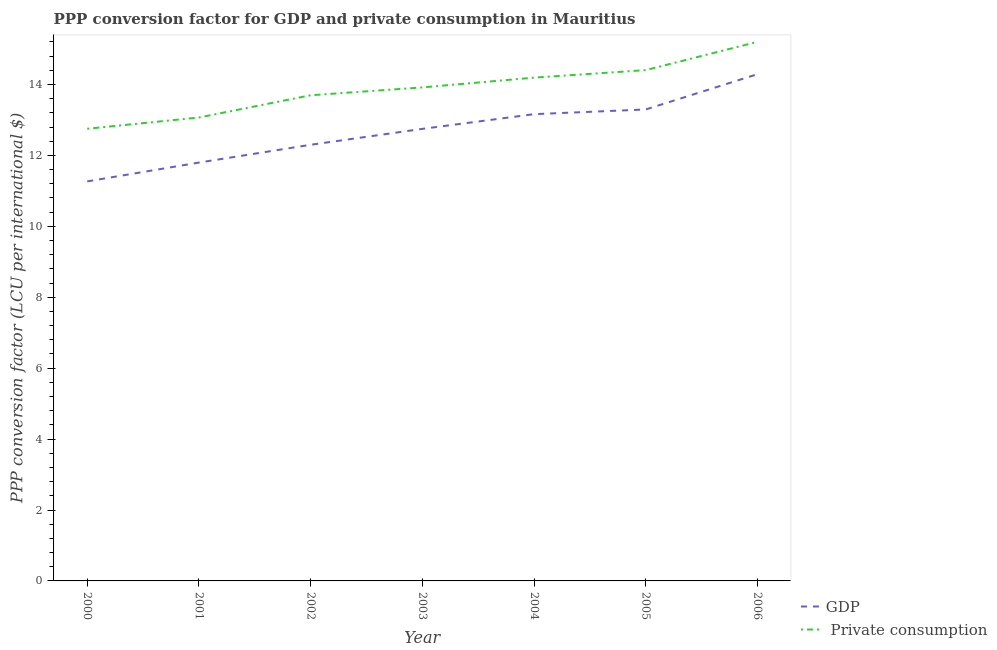How many different coloured lines are there?
Your response must be concise. 2. What is the ppp conversion factor for gdp in 2002?
Offer a very short reply. 12.3. Across all years, what is the maximum ppp conversion factor for private consumption?
Make the answer very short. 15.2. Across all years, what is the minimum ppp conversion factor for gdp?
Your response must be concise. 11.27. What is the total ppp conversion factor for private consumption in the graph?
Provide a short and direct response. 97.24. What is the difference between the ppp conversion factor for private consumption in 2001 and that in 2003?
Provide a short and direct response. -0.85. What is the difference between the ppp conversion factor for private consumption in 2003 and the ppp conversion factor for gdp in 2001?
Your answer should be compact. 2.12. What is the average ppp conversion factor for gdp per year?
Offer a terse response. 12.7. In the year 2003, what is the difference between the ppp conversion factor for gdp and ppp conversion factor for private consumption?
Provide a short and direct response. -1.17. In how many years, is the ppp conversion factor for private consumption greater than 11.2 LCU?
Your answer should be very brief. 7. What is the ratio of the ppp conversion factor for private consumption in 2000 to that in 2002?
Offer a very short reply. 0.93. Is the ppp conversion factor for private consumption in 2000 less than that in 2001?
Your response must be concise. Yes. Is the difference between the ppp conversion factor for private consumption in 2001 and 2002 greater than the difference between the ppp conversion factor for gdp in 2001 and 2002?
Offer a very short reply. No. What is the difference between the highest and the second highest ppp conversion factor for gdp?
Your answer should be very brief. 0.99. What is the difference between the highest and the lowest ppp conversion factor for gdp?
Give a very brief answer. 3.02. In how many years, is the ppp conversion factor for gdp greater than the average ppp conversion factor for gdp taken over all years?
Give a very brief answer. 4. Does the ppp conversion factor for gdp monotonically increase over the years?
Make the answer very short. Yes. How many years are there in the graph?
Give a very brief answer. 7. What is the difference between two consecutive major ticks on the Y-axis?
Provide a succinct answer. 2. How many legend labels are there?
Give a very brief answer. 2. What is the title of the graph?
Offer a very short reply. PPP conversion factor for GDP and private consumption in Mauritius. What is the label or title of the X-axis?
Make the answer very short. Year. What is the label or title of the Y-axis?
Your answer should be very brief. PPP conversion factor (LCU per international $). What is the PPP conversion factor (LCU per international $) in GDP in 2000?
Ensure brevity in your answer.  11.27. What is the PPP conversion factor (LCU per international $) of  Private consumption in 2000?
Your answer should be compact. 12.75. What is the PPP conversion factor (LCU per international $) in GDP in 2001?
Offer a terse response. 11.8. What is the PPP conversion factor (LCU per international $) of  Private consumption in 2001?
Your response must be concise. 13.07. What is the PPP conversion factor (LCU per international $) in GDP in 2002?
Offer a terse response. 12.3. What is the PPP conversion factor (LCU per international $) of  Private consumption in 2002?
Your answer should be compact. 13.7. What is the PPP conversion factor (LCU per international $) of GDP in 2003?
Keep it short and to the point. 12.75. What is the PPP conversion factor (LCU per international $) of  Private consumption in 2003?
Your answer should be compact. 13.92. What is the PPP conversion factor (LCU per international $) of GDP in 2004?
Ensure brevity in your answer.  13.16. What is the PPP conversion factor (LCU per international $) of  Private consumption in 2004?
Make the answer very short. 14.19. What is the PPP conversion factor (LCU per international $) of GDP in 2005?
Keep it short and to the point. 13.3. What is the PPP conversion factor (LCU per international $) in  Private consumption in 2005?
Your answer should be very brief. 14.41. What is the PPP conversion factor (LCU per international $) of GDP in 2006?
Offer a very short reply. 14.29. What is the PPP conversion factor (LCU per international $) of  Private consumption in 2006?
Your response must be concise. 15.2. Across all years, what is the maximum PPP conversion factor (LCU per international $) of GDP?
Provide a short and direct response. 14.29. Across all years, what is the maximum PPP conversion factor (LCU per international $) in  Private consumption?
Make the answer very short. 15.2. Across all years, what is the minimum PPP conversion factor (LCU per international $) of GDP?
Offer a very short reply. 11.27. Across all years, what is the minimum PPP conversion factor (LCU per international $) of  Private consumption?
Keep it short and to the point. 12.75. What is the total PPP conversion factor (LCU per international $) in GDP in the graph?
Your answer should be compact. 88.87. What is the total PPP conversion factor (LCU per international $) in  Private consumption in the graph?
Your answer should be very brief. 97.24. What is the difference between the PPP conversion factor (LCU per international $) in GDP in 2000 and that in 2001?
Provide a short and direct response. -0.53. What is the difference between the PPP conversion factor (LCU per international $) in  Private consumption in 2000 and that in 2001?
Your answer should be very brief. -0.32. What is the difference between the PPP conversion factor (LCU per international $) in GDP in 2000 and that in 2002?
Keep it short and to the point. -1.03. What is the difference between the PPP conversion factor (LCU per international $) of  Private consumption in 2000 and that in 2002?
Offer a terse response. -0.94. What is the difference between the PPP conversion factor (LCU per international $) of GDP in 2000 and that in 2003?
Provide a succinct answer. -1.48. What is the difference between the PPP conversion factor (LCU per international $) in  Private consumption in 2000 and that in 2003?
Provide a succinct answer. -1.17. What is the difference between the PPP conversion factor (LCU per international $) of GDP in 2000 and that in 2004?
Make the answer very short. -1.9. What is the difference between the PPP conversion factor (LCU per international $) in  Private consumption in 2000 and that in 2004?
Give a very brief answer. -1.44. What is the difference between the PPP conversion factor (LCU per international $) of GDP in 2000 and that in 2005?
Your response must be concise. -2.03. What is the difference between the PPP conversion factor (LCU per international $) in  Private consumption in 2000 and that in 2005?
Keep it short and to the point. -1.65. What is the difference between the PPP conversion factor (LCU per international $) in GDP in 2000 and that in 2006?
Provide a succinct answer. -3.02. What is the difference between the PPP conversion factor (LCU per international $) of  Private consumption in 2000 and that in 2006?
Ensure brevity in your answer.  -2.45. What is the difference between the PPP conversion factor (LCU per international $) in GDP in 2001 and that in 2002?
Ensure brevity in your answer.  -0.5. What is the difference between the PPP conversion factor (LCU per international $) of  Private consumption in 2001 and that in 2002?
Your response must be concise. -0.63. What is the difference between the PPP conversion factor (LCU per international $) in GDP in 2001 and that in 2003?
Your response must be concise. -0.95. What is the difference between the PPP conversion factor (LCU per international $) in  Private consumption in 2001 and that in 2003?
Your response must be concise. -0.85. What is the difference between the PPP conversion factor (LCU per international $) in GDP in 2001 and that in 2004?
Make the answer very short. -1.37. What is the difference between the PPP conversion factor (LCU per international $) of  Private consumption in 2001 and that in 2004?
Give a very brief answer. -1.12. What is the difference between the PPP conversion factor (LCU per international $) of GDP in 2001 and that in 2005?
Keep it short and to the point. -1.5. What is the difference between the PPP conversion factor (LCU per international $) of  Private consumption in 2001 and that in 2005?
Your response must be concise. -1.34. What is the difference between the PPP conversion factor (LCU per international $) of GDP in 2001 and that in 2006?
Your response must be concise. -2.49. What is the difference between the PPP conversion factor (LCU per international $) in  Private consumption in 2001 and that in 2006?
Offer a very short reply. -2.13. What is the difference between the PPP conversion factor (LCU per international $) in GDP in 2002 and that in 2003?
Provide a succinct answer. -0.45. What is the difference between the PPP conversion factor (LCU per international $) in  Private consumption in 2002 and that in 2003?
Offer a terse response. -0.22. What is the difference between the PPP conversion factor (LCU per international $) of GDP in 2002 and that in 2004?
Make the answer very short. -0.86. What is the difference between the PPP conversion factor (LCU per international $) in  Private consumption in 2002 and that in 2004?
Keep it short and to the point. -0.5. What is the difference between the PPP conversion factor (LCU per international $) of GDP in 2002 and that in 2005?
Ensure brevity in your answer.  -1. What is the difference between the PPP conversion factor (LCU per international $) in  Private consumption in 2002 and that in 2005?
Provide a succinct answer. -0.71. What is the difference between the PPP conversion factor (LCU per international $) of GDP in 2002 and that in 2006?
Provide a succinct answer. -1.99. What is the difference between the PPP conversion factor (LCU per international $) of  Private consumption in 2002 and that in 2006?
Keep it short and to the point. -1.51. What is the difference between the PPP conversion factor (LCU per international $) in GDP in 2003 and that in 2004?
Keep it short and to the point. -0.41. What is the difference between the PPP conversion factor (LCU per international $) of  Private consumption in 2003 and that in 2004?
Offer a very short reply. -0.28. What is the difference between the PPP conversion factor (LCU per international $) in GDP in 2003 and that in 2005?
Offer a very short reply. -0.55. What is the difference between the PPP conversion factor (LCU per international $) in  Private consumption in 2003 and that in 2005?
Offer a very short reply. -0.49. What is the difference between the PPP conversion factor (LCU per international $) in GDP in 2003 and that in 2006?
Your response must be concise. -1.54. What is the difference between the PPP conversion factor (LCU per international $) in  Private consumption in 2003 and that in 2006?
Ensure brevity in your answer.  -1.28. What is the difference between the PPP conversion factor (LCU per international $) in GDP in 2004 and that in 2005?
Give a very brief answer. -0.13. What is the difference between the PPP conversion factor (LCU per international $) of  Private consumption in 2004 and that in 2005?
Ensure brevity in your answer.  -0.21. What is the difference between the PPP conversion factor (LCU per international $) in GDP in 2004 and that in 2006?
Offer a very short reply. -1.13. What is the difference between the PPP conversion factor (LCU per international $) in  Private consumption in 2004 and that in 2006?
Ensure brevity in your answer.  -1.01. What is the difference between the PPP conversion factor (LCU per international $) of GDP in 2005 and that in 2006?
Offer a terse response. -0.99. What is the difference between the PPP conversion factor (LCU per international $) of  Private consumption in 2005 and that in 2006?
Your answer should be very brief. -0.8. What is the difference between the PPP conversion factor (LCU per international $) of GDP in 2000 and the PPP conversion factor (LCU per international $) of  Private consumption in 2001?
Give a very brief answer. -1.8. What is the difference between the PPP conversion factor (LCU per international $) of GDP in 2000 and the PPP conversion factor (LCU per international $) of  Private consumption in 2002?
Keep it short and to the point. -2.43. What is the difference between the PPP conversion factor (LCU per international $) of GDP in 2000 and the PPP conversion factor (LCU per international $) of  Private consumption in 2003?
Your answer should be very brief. -2.65. What is the difference between the PPP conversion factor (LCU per international $) of GDP in 2000 and the PPP conversion factor (LCU per international $) of  Private consumption in 2004?
Keep it short and to the point. -2.93. What is the difference between the PPP conversion factor (LCU per international $) in GDP in 2000 and the PPP conversion factor (LCU per international $) in  Private consumption in 2005?
Your answer should be compact. -3.14. What is the difference between the PPP conversion factor (LCU per international $) of GDP in 2000 and the PPP conversion factor (LCU per international $) of  Private consumption in 2006?
Your response must be concise. -3.94. What is the difference between the PPP conversion factor (LCU per international $) of GDP in 2001 and the PPP conversion factor (LCU per international $) of  Private consumption in 2002?
Your answer should be compact. -1.9. What is the difference between the PPP conversion factor (LCU per international $) in GDP in 2001 and the PPP conversion factor (LCU per international $) in  Private consumption in 2003?
Make the answer very short. -2.12. What is the difference between the PPP conversion factor (LCU per international $) in GDP in 2001 and the PPP conversion factor (LCU per international $) in  Private consumption in 2004?
Make the answer very short. -2.4. What is the difference between the PPP conversion factor (LCU per international $) of GDP in 2001 and the PPP conversion factor (LCU per international $) of  Private consumption in 2005?
Offer a terse response. -2.61. What is the difference between the PPP conversion factor (LCU per international $) in GDP in 2001 and the PPP conversion factor (LCU per international $) in  Private consumption in 2006?
Make the answer very short. -3.4. What is the difference between the PPP conversion factor (LCU per international $) of GDP in 2002 and the PPP conversion factor (LCU per international $) of  Private consumption in 2003?
Give a very brief answer. -1.62. What is the difference between the PPP conversion factor (LCU per international $) of GDP in 2002 and the PPP conversion factor (LCU per international $) of  Private consumption in 2004?
Provide a short and direct response. -1.89. What is the difference between the PPP conversion factor (LCU per international $) of GDP in 2002 and the PPP conversion factor (LCU per international $) of  Private consumption in 2005?
Your answer should be compact. -2.11. What is the difference between the PPP conversion factor (LCU per international $) of GDP in 2002 and the PPP conversion factor (LCU per international $) of  Private consumption in 2006?
Offer a very short reply. -2.9. What is the difference between the PPP conversion factor (LCU per international $) in GDP in 2003 and the PPP conversion factor (LCU per international $) in  Private consumption in 2004?
Offer a very short reply. -1.44. What is the difference between the PPP conversion factor (LCU per international $) of GDP in 2003 and the PPP conversion factor (LCU per international $) of  Private consumption in 2005?
Provide a short and direct response. -1.66. What is the difference between the PPP conversion factor (LCU per international $) of GDP in 2003 and the PPP conversion factor (LCU per international $) of  Private consumption in 2006?
Make the answer very short. -2.45. What is the difference between the PPP conversion factor (LCU per international $) in GDP in 2004 and the PPP conversion factor (LCU per international $) in  Private consumption in 2005?
Keep it short and to the point. -1.24. What is the difference between the PPP conversion factor (LCU per international $) of GDP in 2004 and the PPP conversion factor (LCU per international $) of  Private consumption in 2006?
Make the answer very short. -2.04. What is the difference between the PPP conversion factor (LCU per international $) in GDP in 2005 and the PPP conversion factor (LCU per international $) in  Private consumption in 2006?
Provide a succinct answer. -1.91. What is the average PPP conversion factor (LCU per international $) in GDP per year?
Keep it short and to the point. 12.7. What is the average PPP conversion factor (LCU per international $) of  Private consumption per year?
Make the answer very short. 13.89. In the year 2000, what is the difference between the PPP conversion factor (LCU per international $) of GDP and PPP conversion factor (LCU per international $) of  Private consumption?
Your answer should be compact. -1.48. In the year 2001, what is the difference between the PPP conversion factor (LCU per international $) of GDP and PPP conversion factor (LCU per international $) of  Private consumption?
Your response must be concise. -1.27. In the year 2002, what is the difference between the PPP conversion factor (LCU per international $) of GDP and PPP conversion factor (LCU per international $) of  Private consumption?
Give a very brief answer. -1.4. In the year 2003, what is the difference between the PPP conversion factor (LCU per international $) in GDP and PPP conversion factor (LCU per international $) in  Private consumption?
Give a very brief answer. -1.17. In the year 2004, what is the difference between the PPP conversion factor (LCU per international $) in GDP and PPP conversion factor (LCU per international $) in  Private consumption?
Make the answer very short. -1.03. In the year 2005, what is the difference between the PPP conversion factor (LCU per international $) of GDP and PPP conversion factor (LCU per international $) of  Private consumption?
Offer a very short reply. -1.11. In the year 2006, what is the difference between the PPP conversion factor (LCU per international $) of GDP and PPP conversion factor (LCU per international $) of  Private consumption?
Your response must be concise. -0.91. What is the ratio of the PPP conversion factor (LCU per international $) in GDP in 2000 to that in 2001?
Provide a short and direct response. 0.95. What is the ratio of the PPP conversion factor (LCU per international $) in  Private consumption in 2000 to that in 2001?
Your answer should be very brief. 0.98. What is the ratio of the PPP conversion factor (LCU per international $) of GDP in 2000 to that in 2002?
Offer a terse response. 0.92. What is the ratio of the PPP conversion factor (LCU per international $) of  Private consumption in 2000 to that in 2002?
Give a very brief answer. 0.93. What is the ratio of the PPP conversion factor (LCU per international $) of GDP in 2000 to that in 2003?
Make the answer very short. 0.88. What is the ratio of the PPP conversion factor (LCU per international $) of  Private consumption in 2000 to that in 2003?
Your response must be concise. 0.92. What is the ratio of the PPP conversion factor (LCU per international $) in GDP in 2000 to that in 2004?
Ensure brevity in your answer.  0.86. What is the ratio of the PPP conversion factor (LCU per international $) in  Private consumption in 2000 to that in 2004?
Offer a terse response. 0.9. What is the ratio of the PPP conversion factor (LCU per international $) of GDP in 2000 to that in 2005?
Your answer should be very brief. 0.85. What is the ratio of the PPP conversion factor (LCU per international $) of  Private consumption in 2000 to that in 2005?
Give a very brief answer. 0.89. What is the ratio of the PPP conversion factor (LCU per international $) of GDP in 2000 to that in 2006?
Offer a terse response. 0.79. What is the ratio of the PPP conversion factor (LCU per international $) of  Private consumption in 2000 to that in 2006?
Keep it short and to the point. 0.84. What is the ratio of the PPP conversion factor (LCU per international $) in GDP in 2001 to that in 2002?
Provide a succinct answer. 0.96. What is the ratio of the PPP conversion factor (LCU per international $) of  Private consumption in 2001 to that in 2002?
Your answer should be compact. 0.95. What is the ratio of the PPP conversion factor (LCU per international $) of GDP in 2001 to that in 2003?
Offer a very short reply. 0.93. What is the ratio of the PPP conversion factor (LCU per international $) in  Private consumption in 2001 to that in 2003?
Give a very brief answer. 0.94. What is the ratio of the PPP conversion factor (LCU per international $) in GDP in 2001 to that in 2004?
Give a very brief answer. 0.9. What is the ratio of the PPP conversion factor (LCU per international $) in  Private consumption in 2001 to that in 2004?
Your answer should be very brief. 0.92. What is the ratio of the PPP conversion factor (LCU per international $) of GDP in 2001 to that in 2005?
Offer a terse response. 0.89. What is the ratio of the PPP conversion factor (LCU per international $) in  Private consumption in 2001 to that in 2005?
Your response must be concise. 0.91. What is the ratio of the PPP conversion factor (LCU per international $) of GDP in 2001 to that in 2006?
Offer a very short reply. 0.83. What is the ratio of the PPP conversion factor (LCU per international $) of  Private consumption in 2001 to that in 2006?
Ensure brevity in your answer.  0.86. What is the ratio of the PPP conversion factor (LCU per international $) in GDP in 2002 to that in 2003?
Your answer should be compact. 0.96. What is the ratio of the PPP conversion factor (LCU per international $) of  Private consumption in 2002 to that in 2003?
Keep it short and to the point. 0.98. What is the ratio of the PPP conversion factor (LCU per international $) of GDP in 2002 to that in 2004?
Offer a very short reply. 0.93. What is the ratio of the PPP conversion factor (LCU per international $) in  Private consumption in 2002 to that in 2004?
Ensure brevity in your answer.  0.96. What is the ratio of the PPP conversion factor (LCU per international $) of GDP in 2002 to that in 2005?
Provide a succinct answer. 0.93. What is the ratio of the PPP conversion factor (LCU per international $) of  Private consumption in 2002 to that in 2005?
Give a very brief answer. 0.95. What is the ratio of the PPP conversion factor (LCU per international $) in GDP in 2002 to that in 2006?
Give a very brief answer. 0.86. What is the ratio of the PPP conversion factor (LCU per international $) in  Private consumption in 2002 to that in 2006?
Keep it short and to the point. 0.9. What is the ratio of the PPP conversion factor (LCU per international $) of GDP in 2003 to that in 2004?
Keep it short and to the point. 0.97. What is the ratio of the PPP conversion factor (LCU per international $) in  Private consumption in 2003 to that in 2004?
Offer a very short reply. 0.98. What is the ratio of the PPP conversion factor (LCU per international $) in GDP in 2003 to that in 2005?
Provide a short and direct response. 0.96. What is the ratio of the PPP conversion factor (LCU per international $) of  Private consumption in 2003 to that in 2005?
Make the answer very short. 0.97. What is the ratio of the PPP conversion factor (LCU per international $) in GDP in 2003 to that in 2006?
Give a very brief answer. 0.89. What is the ratio of the PPP conversion factor (LCU per international $) in  Private consumption in 2003 to that in 2006?
Your response must be concise. 0.92. What is the ratio of the PPP conversion factor (LCU per international $) in GDP in 2004 to that in 2005?
Keep it short and to the point. 0.99. What is the ratio of the PPP conversion factor (LCU per international $) in  Private consumption in 2004 to that in 2005?
Offer a terse response. 0.99. What is the ratio of the PPP conversion factor (LCU per international $) in GDP in 2004 to that in 2006?
Provide a succinct answer. 0.92. What is the ratio of the PPP conversion factor (LCU per international $) in  Private consumption in 2004 to that in 2006?
Provide a succinct answer. 0.93. What is the ratio of the PPP conversion factor (LCU per international $) in GDP in 2005 to that in 2006?
Your response must be concise. 0.93. What is the ratio of the PPP conversion factor (LCU per international $) in  Private consumption in 2005 to that in 2006?
Offer a terse response. 0.95. What is the difference between the highest and the second highest PPP conversion factor (LCU per international $) of  Private consumption?
Provide a succinct answer. 0.8. What is the difference between the highest and the lowest PPP conversion factor (LCU per international $) in GDP?
Offer a terse response. 3.02. What is the difference between the highest and the lowest PPP conversion factor (LCU per international $) of  Private consumption?
Ensure brevity in your answer.  2.45. 